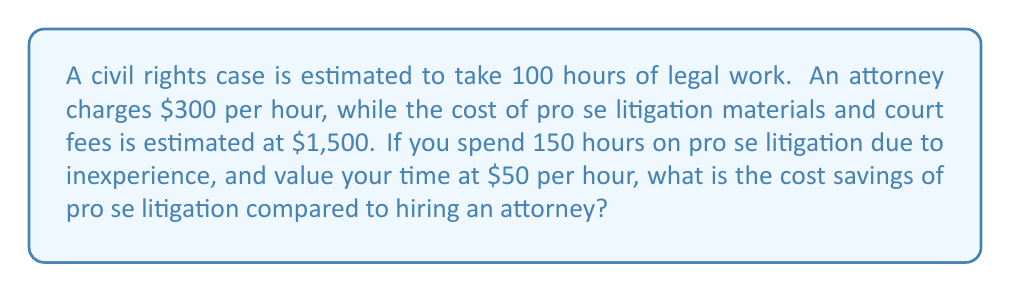Provide a solution to this math problem. Let's break this down step-by-step:

1) Cost of hiring an attorney:
   $$ C_a = 100 \text{ hours} \times \$300/\text{hour} = \$30,000 $$

2) Cost of pro se litigation:
   a) Materials and court fees: $1,500
   b) Value of personal time: $$ 150 \text{ hours} \times \$50/\text{hour} = \$7,500 $$
   c) Total pro se cost: $$ C_p = \$1,500 + \$7,500 = \$9,000 $$

3) Cost savings:
   $$ \text{Savings} = C_a - C_p = \$30,000 - \$9,000 = \$21,000 $$

Therefore, the cost savings of pro se litigation in this scenario is $21,000.
Answer: $21,000 